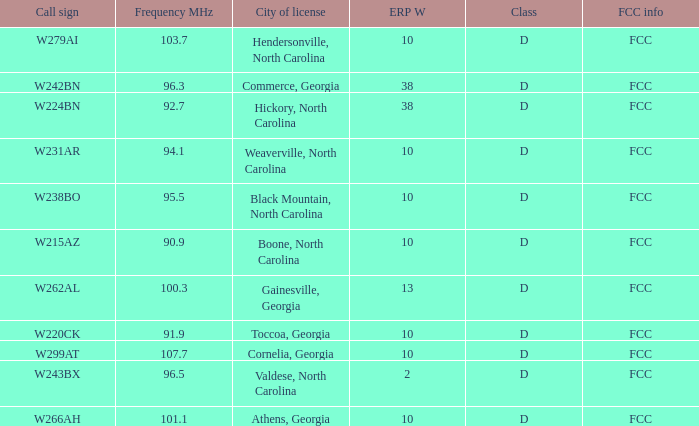What is the FCC frequency for the station w262al which has a Frequency MHz larger than 92.7? FCC. 